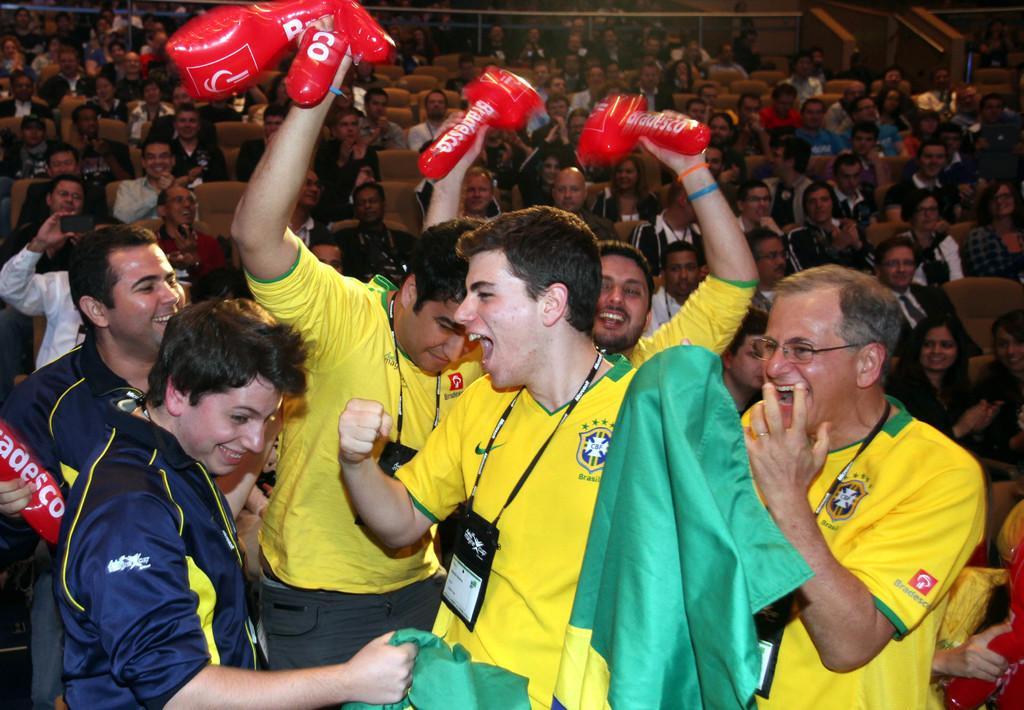Please provide a concise description of this image. In this image there are many people. In the foreground there are a few people standing and smiling. They are holding a few objects in their hands. In the background there are spectators sitting on the chairs. 